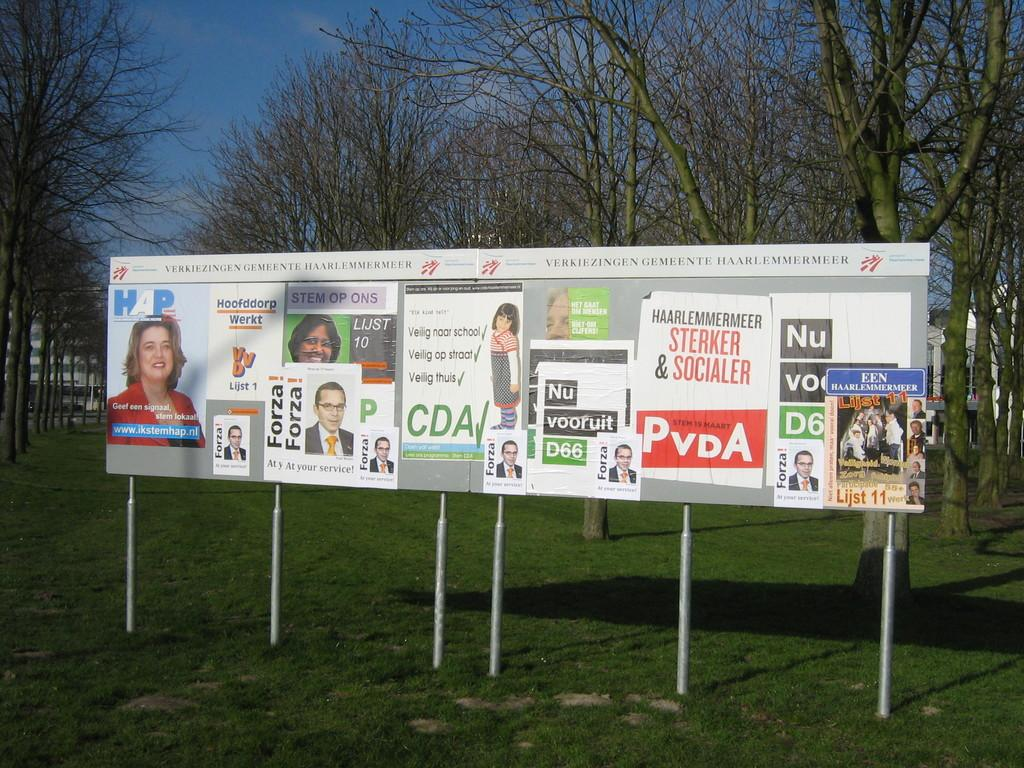<image>
Offer a succinct explanation of the picture presented. A collection of posters on display, the middle one with the leters CDA. 